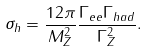<formula> <loc_0><loc_0><loc_500><loc_500>\sigma _ { h } = \frac { 1 2 \pi } { M _ { Z } ^ { 2 } } \frac { \Gamma _ { e e } \Gamma _ { h a d } } { \Gamma _ { Z } ^ { 2 } } .</formula> 